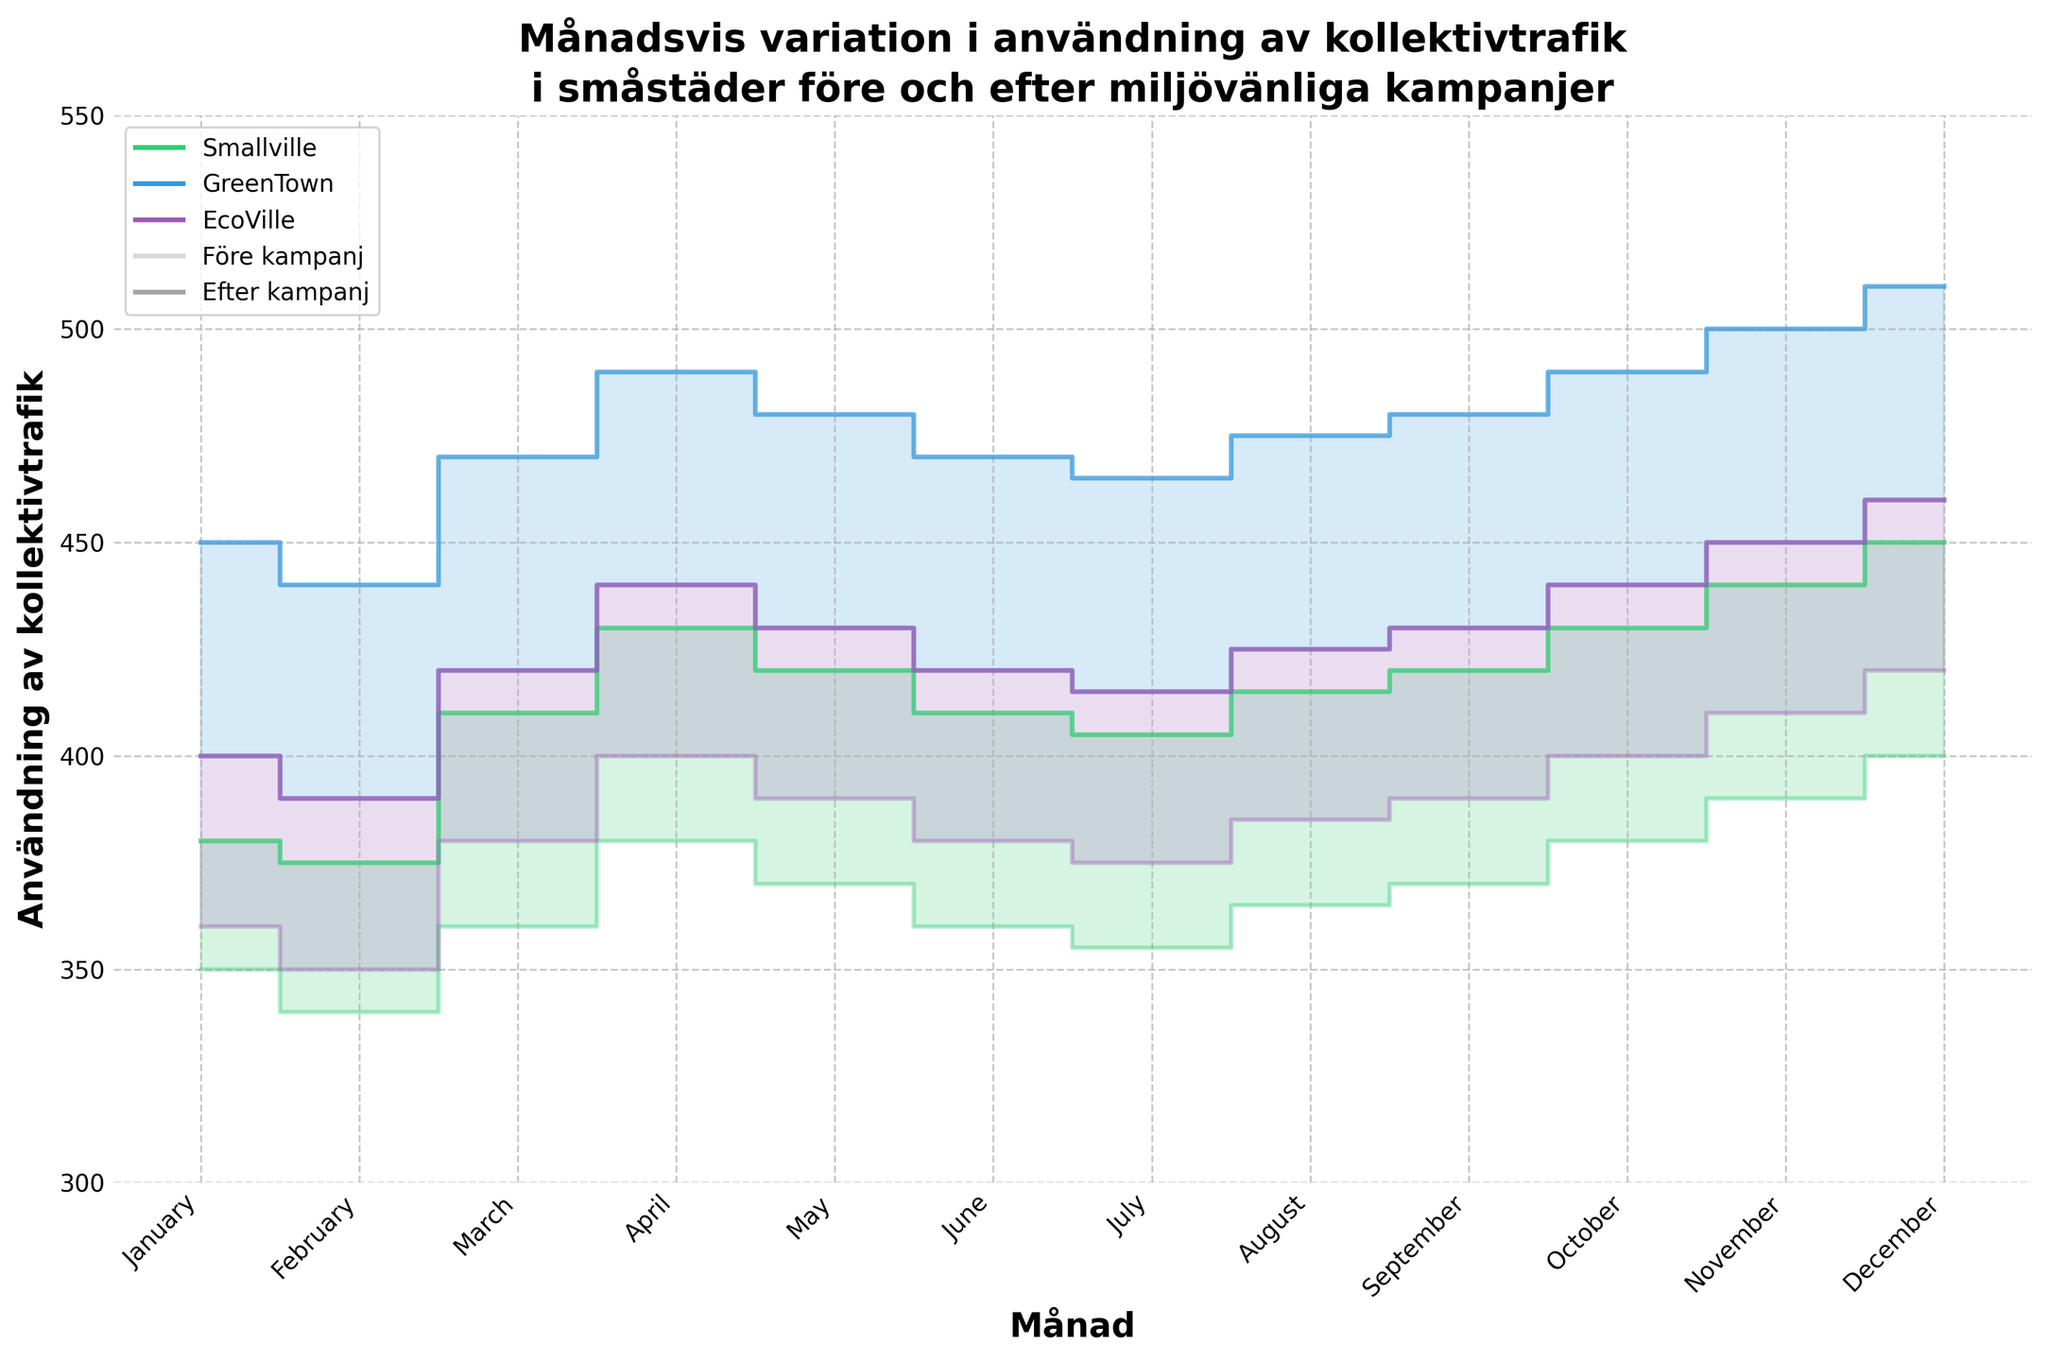What is the title of the figure? The title is found at the top of the chart, conveying the main subject of the data being presented.
Answer: Månadsvis variation i användning av kollektivtrafik i småstäder före och efter miljövänliga kampanjer Which month shows the highest usage of public transportation in GreenTown before the campaign? This can be determined by examining the GreenTown_Before line and identifying the peak point.
Answer: December How does the public transportation usage in EcoVille change from February to March after the campaign? To find this, observe the EcoVille_After line and compare the values for February and March.
Answer: It increases by 30 (from 390 to 420) Which town shows the most significant increase in public transportation usage after the campaigns across most months? Compare the step areas of all towns (Smallville, GreenTown, and EcoVille) and see which town has the largest filled area between the 'Before' and 'After' lines.
Answer: GreenTown By how much did the public transportation usage increase in Smallville from January to December after the campaign? Look at the Smallville_After line and calculate the difference between its value in January and December.
Answer: 70 (from 380 to 450) Does any town show a decrease in public transportation usage in any month after the campaign? Examine the 'After' lines for all towns and check if any dip below the previous month's value.
Answer: No Between which consecutive months does GreenTown see the largest increase in public transportation usage after the campaign? Analyze the GreenTown_After line and determine where the steepest increase occurs between two consecutive months.
Answer: November to December Compare the difference in public transportation usage between the before and after campaigns for Smallville in November. Subtract the Smallville_Before value from the Smallville_After value for November.
Answer: 50 (440 - 390) What is the average public transportation usage in Smallville before the campaign over the entire year? Sum all the Smallville_Before values for each month and divide by the number of months (12). Calculation: (350+340+360+380+370+360+355+365+370+380+390+400) / 12 = 374.17
Answer: 374.17 Which town had the greatest difference in their usage of public transportation before and after the campaign in October? Calculate the differences for each town in October and determine which one is the largest. Smallville: 430 - 380 = 50, GreenTown: 490 - 440 = 50, EcoVille: 440 - 400 = 40.
Answer: Smallville and GreenTown 